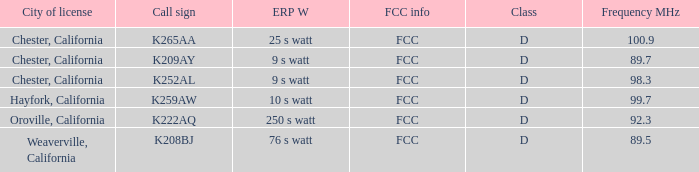Name the call sign with frequency of 89.5 K208BJ. Parse the full table. {'header': ['City of license', 'Call sign', 'ERP W', 'FCC info', 'Class', 'Frequency MHz'], 'rows': [['Chester, California', 'K265AA', '25 s watt', 'FCC', 'D', '100.9'], ['Chester, California', 'K209AY', '9 s watt', 'FCC', 'D', '89.7'], ['Chester, California', 'K252AL', '9 s watt', 'FCC', 'D', '98.3'], ['Hayfork, California', 'K259AW', '10 s watt', 'FCC', 'D', '99.7'], ['Oroville, California', 'K222AQ', '250 s watt', 'FCC', 'D', '92.3'], ['Weaverville, California', 'K208BJ', '76 s watt', 'FCC', 'D', '89.5']]} 